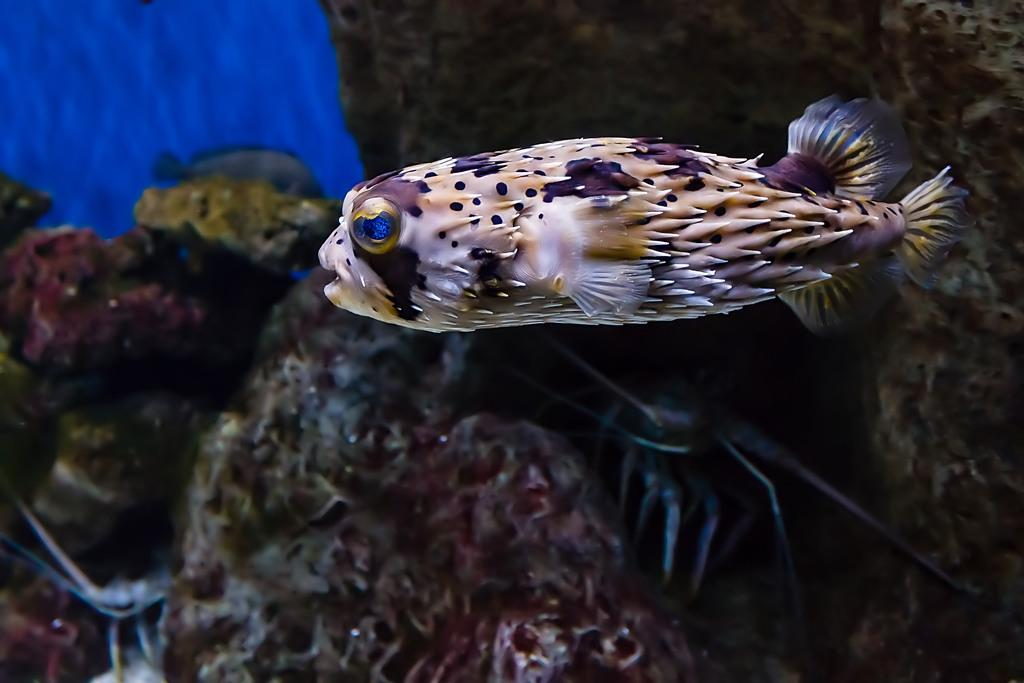What type of animals can be seen in the image? There are fish in the image. What can be seen in the background of the image? There is sea fungus and another fish in the background of the image. What color is present in the top left side of the image? The top left side of the image has a blue color. What type of book is the fish reading in the image? There is no book or reading activity present in the image; it features fish and sea fungus. 